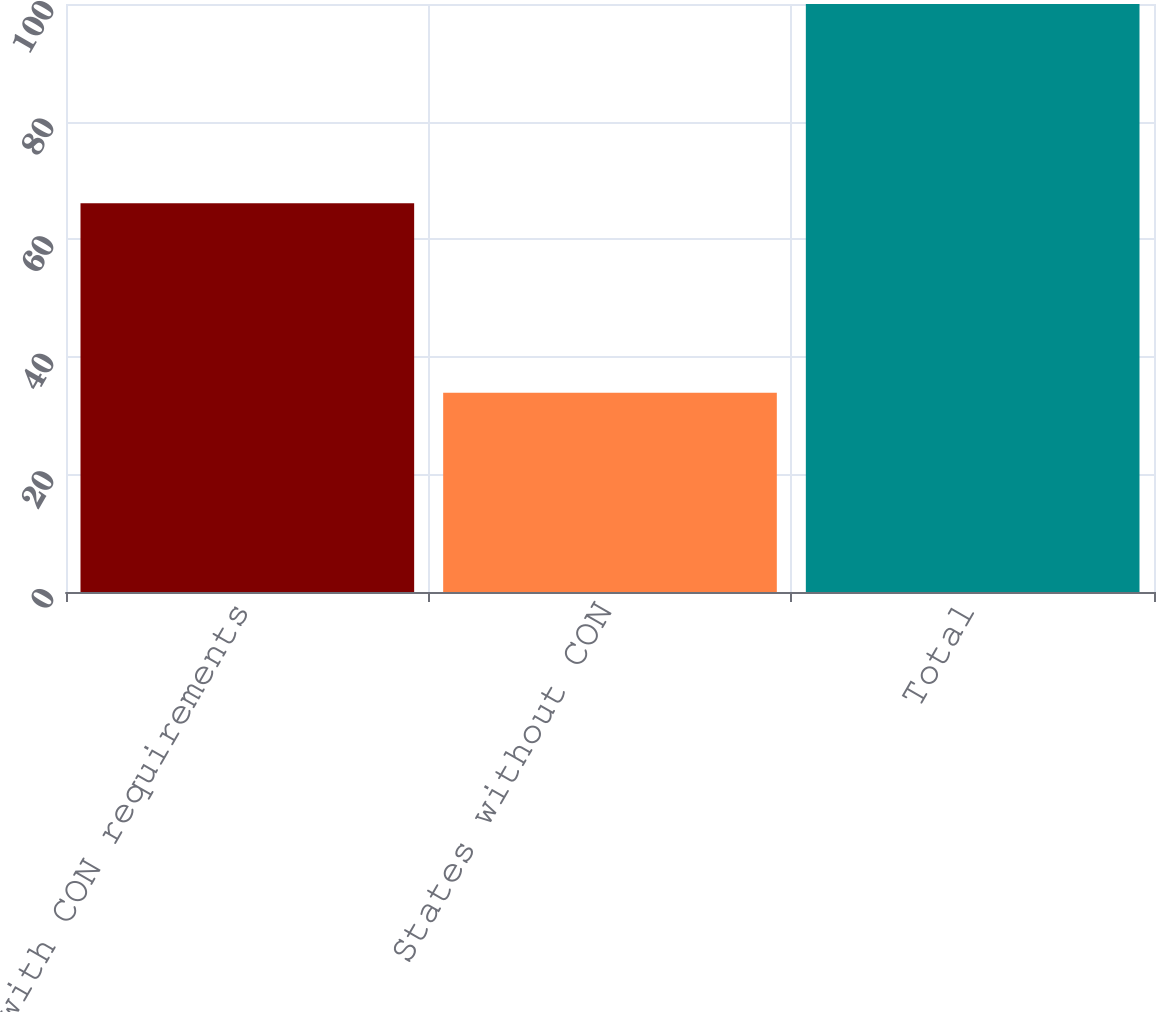<chart> <loc_0><loc_0><loc_500><loc_500><bar_chart><fcel>States with CON requirements<fcel>States without CON<fcel>Total<nl><fcel>66.1<fcel>33.9<fcel>100<nl></chart> 